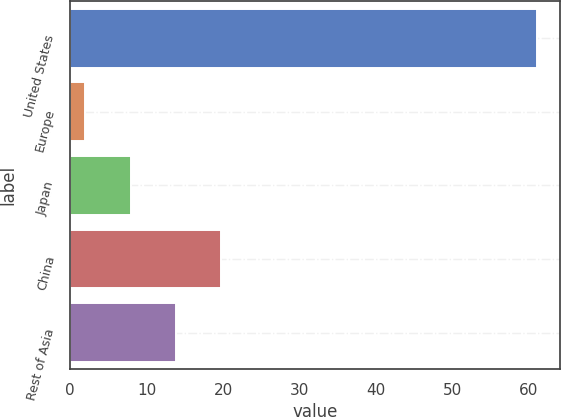<chart> <loc_0><loc_0><loc_500><loc_500><bar_chart><fcel>United States<fcel>Europe<fcel>Japan<fcel>China<fcel>Rest of Asia<nl><fcel>61<fcel>2<fcel>7.9<fcel>19.7<fcel>13.8<nl></chart> 